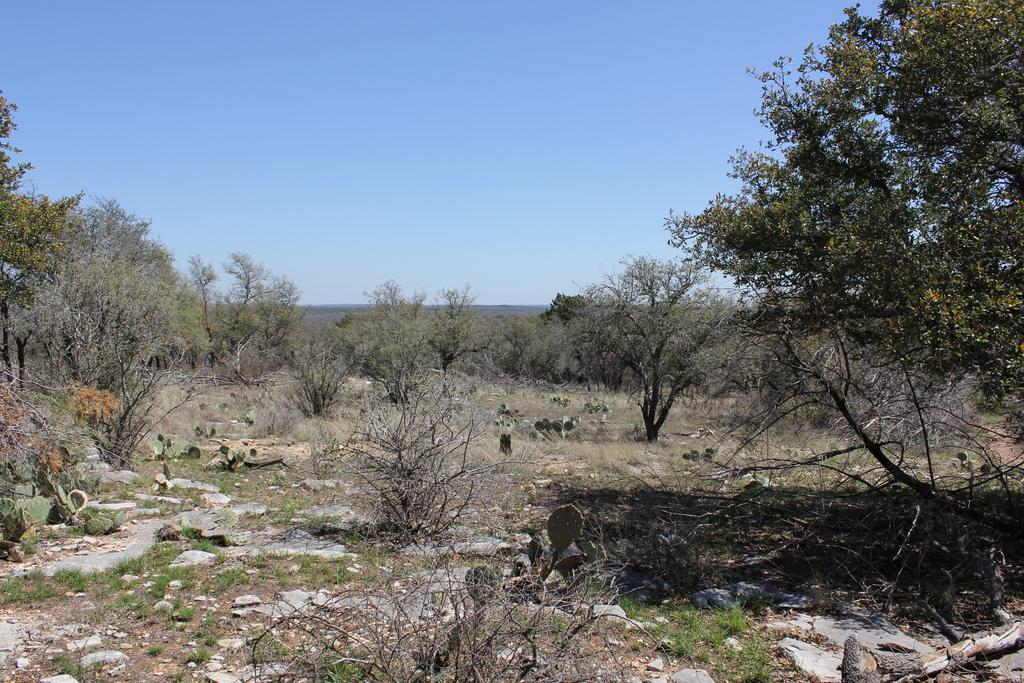What type of vegetation is present in the image? There are trees in the image. What else can be seen on the ground in the image? There are stones in the image. What is visible at the top of the image? The sky is visible at the top of the image. How many pies are being served under the tent with the sheep in the image? There are no pies, tents, or sheep present in the image. 